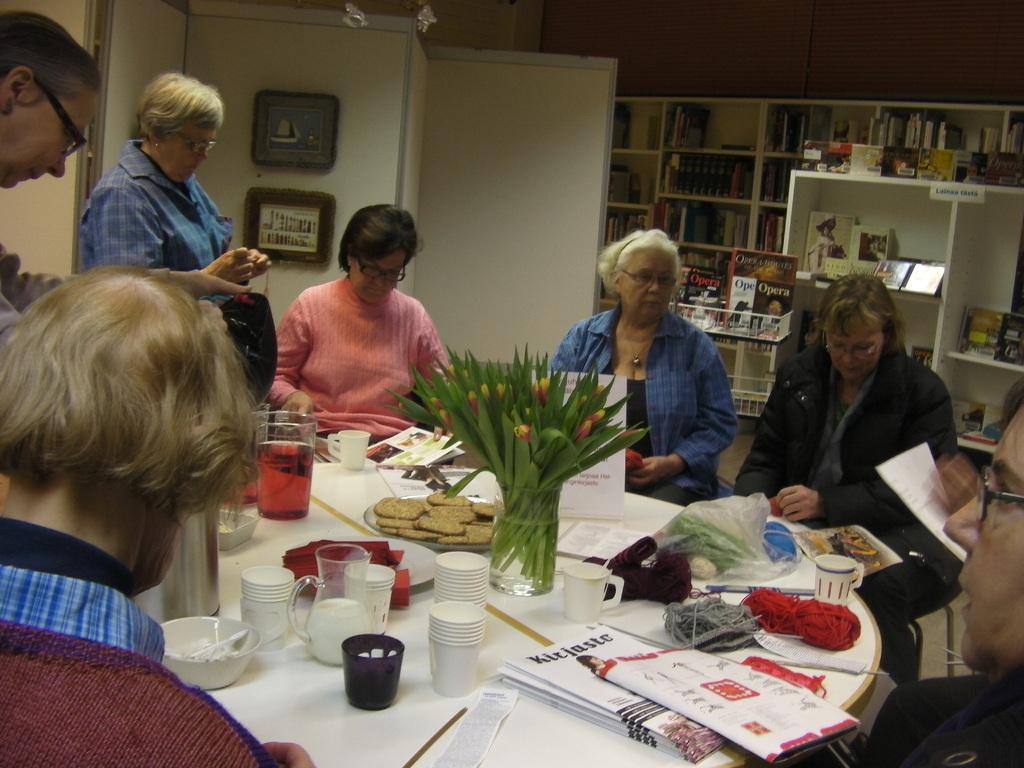Can you describe this image briefly? In this image we can see a few persons, some of them are sitting, in front of them there is a table, on that we can see some cups, glasses, bowls, jar, papers, and some other objects, also we can see the walls, and some books on the racks. 